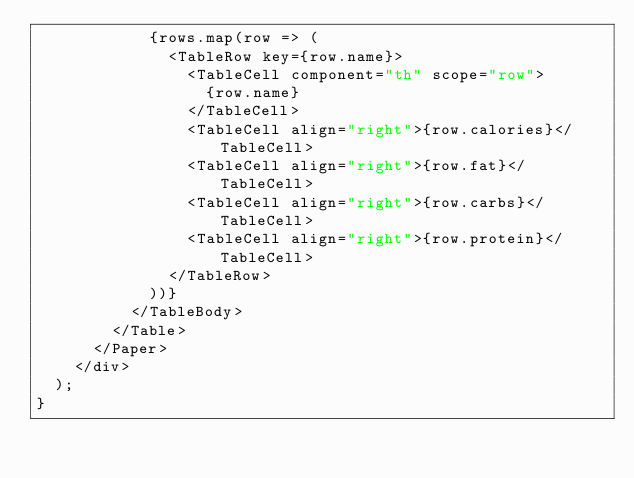<code> <loc_0><loc_0><loc_500><loc_500><_TypeScript_>            {rows.map(row => (
              <TableRow key={row.name}>
                <TableCell component="th" scope="row">
                  {row.name}
                </TableCell>
                <TableCell align="right">{row.calories}</TableCell>
                <TableCell align="right">{row.fat}</TableCell>
                <TableCell align="right">{row.carbs}</TableCell>
                <TableCell align="right">{row.protein}</TableCell>
              </TableRow>
            ))}
          </TableBody>
        </Table>
      </Paper>
    </div>
  );
}
</code> 